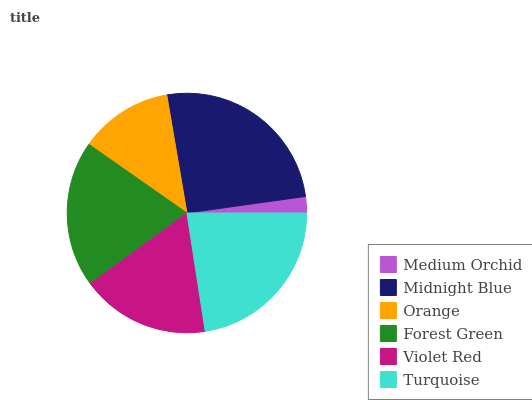Is Medium Orchid the minimum?
Answer yes or no. Yes. Is Midnight Blue the maximum?
Answer yes or no. Yes. Is Orange the minimum?
Answer yes or no. No. Is Orange the maximum?
Answer yes or no. No. Is Midnight Blue greater than Orange?
Answer yes or no. Yes. Is Orange less than Midnight Blue?
Answer yes or no. Yes. Is Orange greater than Midnight Blue?
Answer yes or no. No. Is Midnight Blue less than Orange?
Answer yes or no. No. Is Forest Green the high median?
Answer yes or no. Yes. Is Violet Red the low median?
Answer yes or no. Yes. Is Violet Red the high median?
Answer yes or no. No. Is Forest Green the low median?
Answer yes or no. No. 